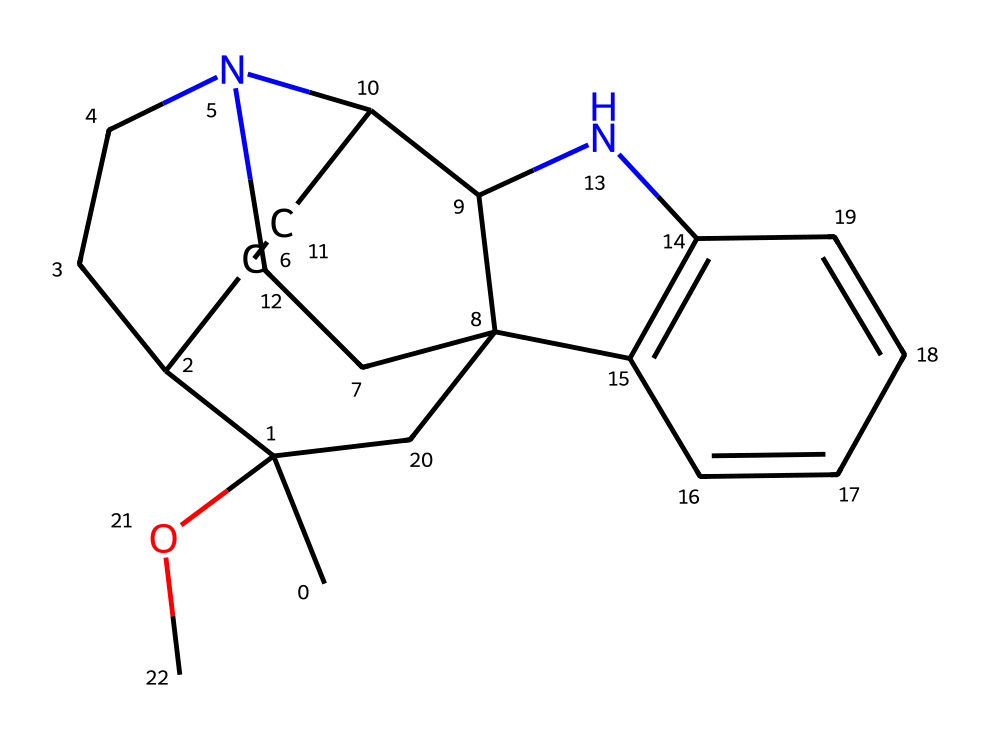How many nitrogen atoms are in ibogaine? In the SMILES representation of ibogaine, we can identify the nitrogen atoms by looking for 'N'. Examining the structure shows two occurrences of 'N', indicating that there are two nitrogen atoms.
Answer: two What is the molecular formula of ibogaine? To derive the molecular formula, count the number of each type of atom in the structure based on the SMILES notation. It reveals 18 carbon (C) atoms, 24 hydrogen (H) atoms, 2 nitrogen (N) atoms, and 1 oxygen (O) atom, leading to the formula C18H24N2O.
Answer: C18H24N2O How many rings are present in the structure of ibogaine? Analyzing the structural formula, we can identify the rings present by locating the cyclical arrangements of atoms, which include connections that return to the initial atom. There are four distinct ring structures present in ibogaine.
Answer: four What type of compound is ibogaine classified as? Ibogaine contains nitrogen atoms within its structure, a characteristic feature of alkaloids. Alkaloids are typically derived from plant sources and frequently contain basic nitrogen atoms, classifying ibogaine as an alkaloid.
Answer: alkaloid Which functional group is present in ibogaine? By examining the structure, we can identify the presence of a hydroxy group (-OH), given that there is an oxygen (O) connected to a carbon skeleton. This classifies ibogaine as having an alcohol functional group.
Answer: alcohol What is the stereocenter count in ibogaine? A stereocenter can be identified by examining the carbon atoms and determining if any are connected to four different substituents. In the structure of ibogaine, there are three such carbon atoms acting as stereocenters.
Answer: three 